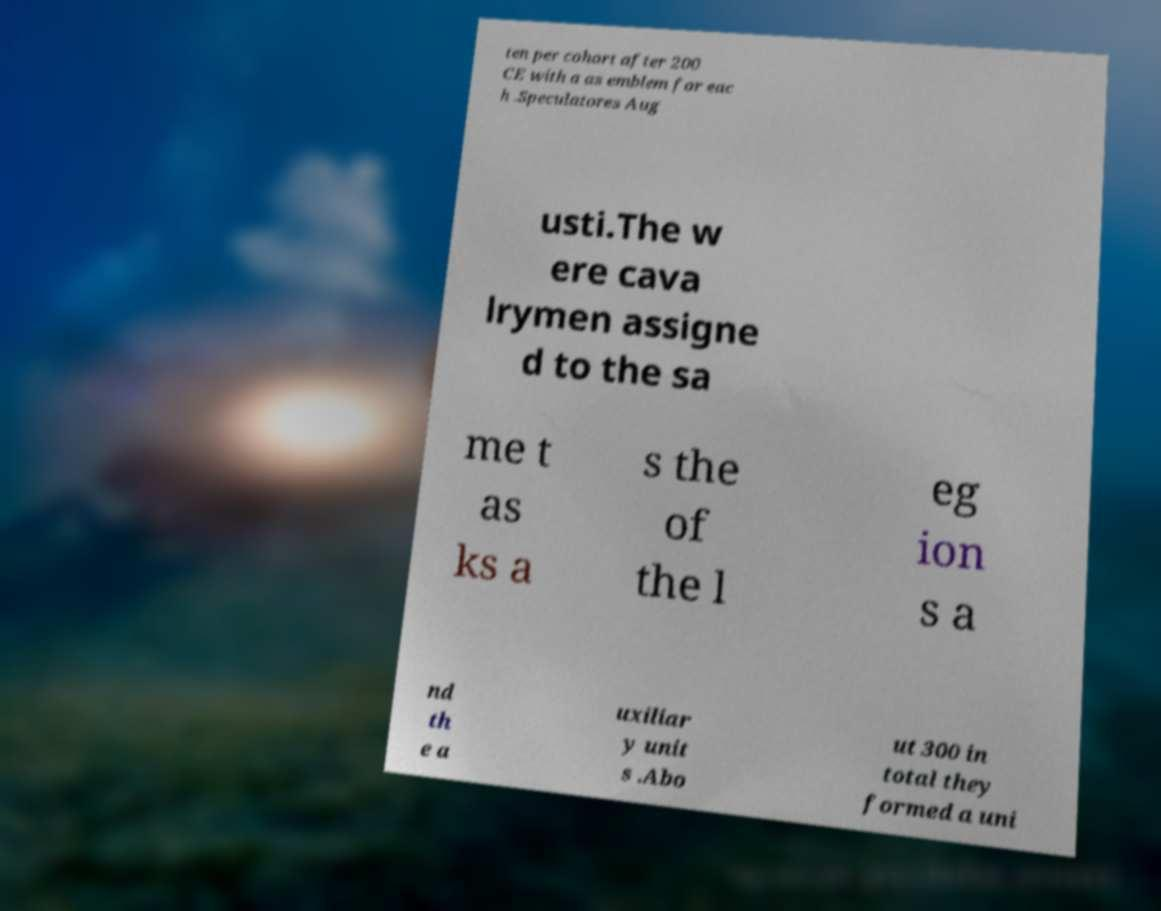I need the written content from this picture converted into text. Can you do that? ten per cohort after 200 CE with a as emblem for eac h .Speculatores Aug usti.The w ere cava lrymen assigne d to the sa me t as ks a s the of the l eg ion s a nd th e a uxiliar y unit s .Abo ut 300 in total they formed a uni 